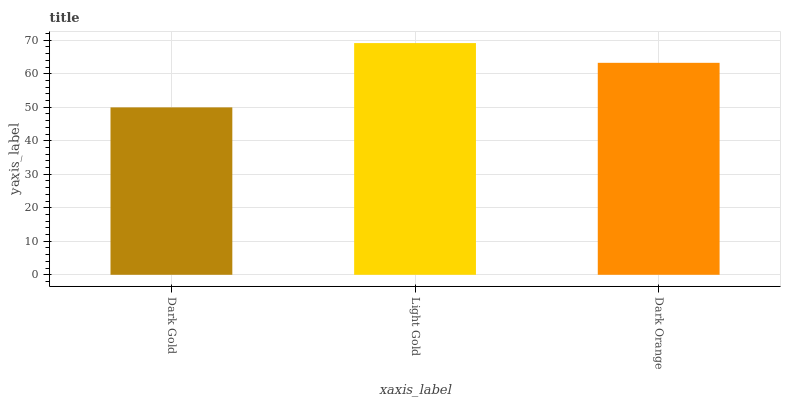Is Dark Gold the minimum?
Answer yes or no. Yes. Is Light Gold the maximum?
Answer yes or no. Yes. Is Dark Orange the minimum?
Answer yes or no. No. Is Dark Orange the maximum?
Answer yes or no. No. Is Light Gold greater than Dark Orange?
Answer yes or no. Yes. Is Dark Orange less than Light Gold?
Answer yes or no. Yes. Is Dark Orange greater than Light Gold?
Answer yes or no. No. Is Light Gold less than Dark Orange?
Answer yes or no. No. Is Dark Orange the high median?
Answer yes or no. Yes. Is Dark Orange the low median?
Answer yes or no. Yes. Is Light Gold the high median?
Answer yes or no. No. Is Light Gold the low median?
Answer yes or no. No. 